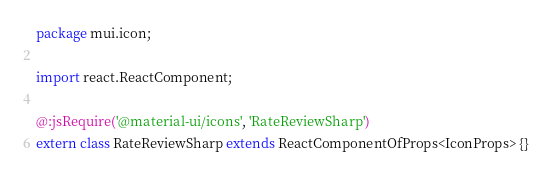Convert code to text. <code><loc_0><loc_0><loc_500><loc_500><_Haxe_>package mui.icon;

import react.ReactComponent;

@:jsRequire('@material-ui/icons', 'RateReviewSharp')
extern class RateReviewSharp extends ReactComponentOfProps<IconProps> {}
</code> 